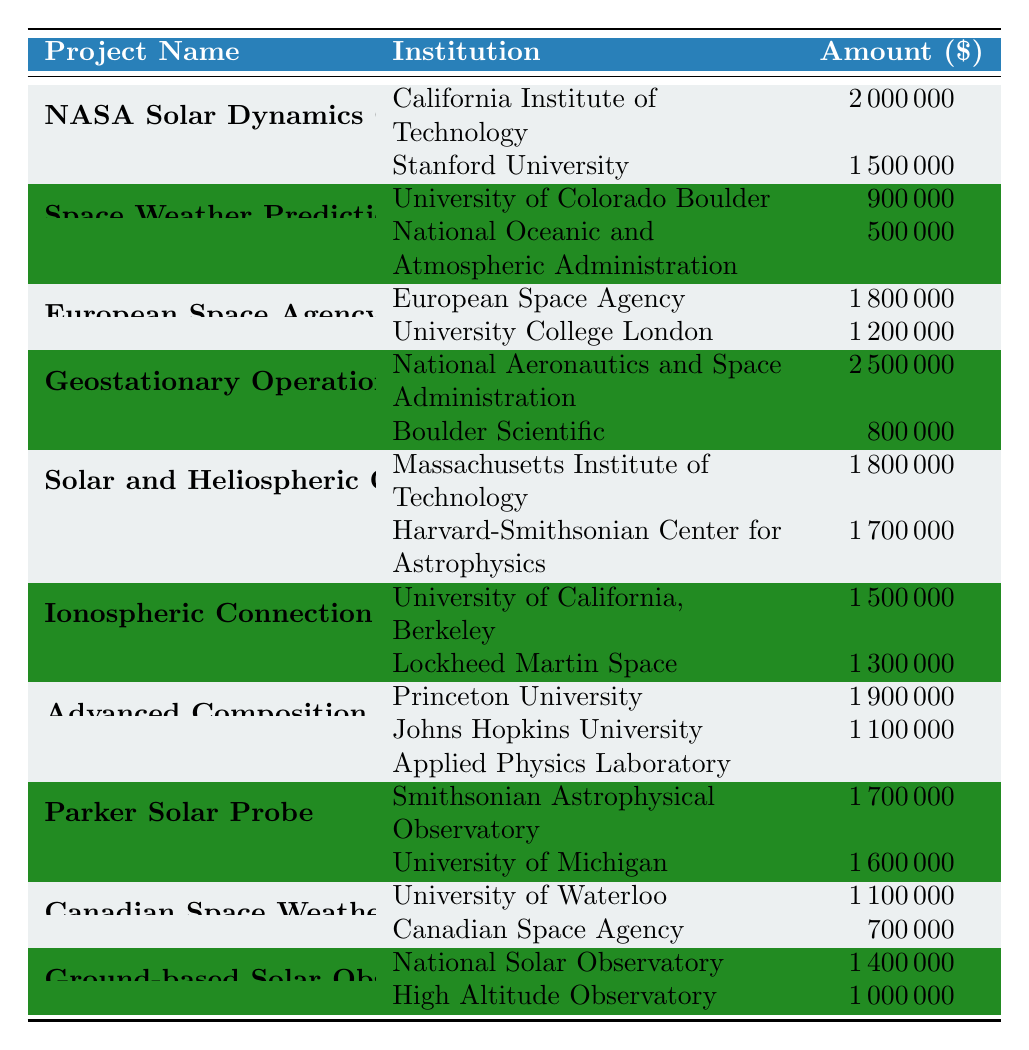What is the total amount funded to the Geostationary Operational Environmental Satellites project? The total funding for the Geostationary Operational Environmental Satellites project includes two institutions: National Aeronautics and Space Administration with 2,500,000 and Boulder Scientific with 800,000. Adding these amounts results in 2,500,000 + 800,000 = 3,300,000.
Answer: 3,300,000 Which project received the highest total funding? To determine which project received the highest total funding, we need to sum the amounts for each project: NASA Solar Dynamics Observatory Research (3,500,000), Space Weather Prediction Center (1,400,000), European Space Agency - Space Weather Coordination (3,000,000), Geostationary Operational Environmental Satellites (3,300,000), Solar and Heliospheric Observatory (3,500,000), Ionospheric Connection Explorer (2,800,000), Advanced Composition Explorer (3,000,000), Parker Solar Probe (3,300,000), Canadian Space Weather Forecast Center (1,800,000), and Ground-based Solar Observatories (2,400,000). The highest funding is 3,500,000 for both NASA Solar Dynamics Observatory Research and Solar and Heliospheric Observatory.
Answer: NASA Solar Dynamics Observatory Research and Solar and Heliospheric Observatory Did the University of California, Berkeley contribute to any project? Yes, the University of California, Berkeley is listed as an institution for the Ionospheric Connection Explorer project with a funding amount of 1,500,000.
Answer: Yes What is the average funding amount across all projects? To calculate the average funding amount, we first need to find the total funding across all listed projects. Summing all unique amounts gives us 3,500,000 + 1,400,000 + 3,000,000 + 3,300,000 + 3,500,000 + 2,800,000 + 3,000,000 + 3,300,000 + 1,800,000 + 2,400,000 = 25,000,000. There are 10 projects, so dividing the total by the number of projects results in 25,000,000 / 10 = 2,500,000.
Answer: 2,500,000 Which institution received funding for the Parker Solar Probe project? The Parker Solar Probe project lists the Smithsonian Astrophysical Observatory with 1,700,000 and University of Michigan with 1,600,000. Therefore, both institutions received funding for this project.
Answer: Smithsonian Astrophysical Observatory and University of Michigan 